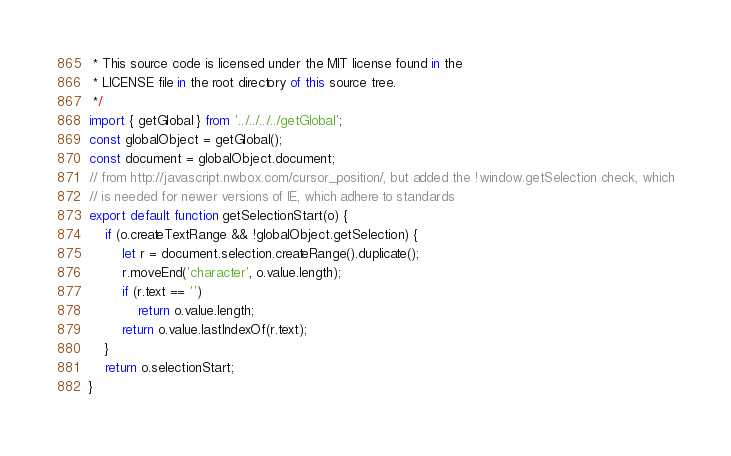Convert code to text. <code><loc_0><loc_0><loc_500><loc_500><_JavaScript_> * This source code is licensed under the MIT license found in the
 * LICENSE file in the root directory of this source tree.
 */
import { getGlobal } from '../../../../getGlobal';
const globalObject = getGlobal();
const document = globalObject.document;
// from http://javascript.nwbox.com/cursor_position/, but added the !window.getSelection check, which
// is needed for newer versions of IE, which adhere to standards
export default function getSelectionStart(o) {
    if (o.createTextRange && !globalObject.getSelection) {
        let r = document.selection.createRange().duplicate();
        r.moveEnd('character', o.value.length);
        if (r.text == '')
            return o.value.length;
        return o.value.lastIndexOf(r.text);
    }
    return o.selectionStart;
}
</code> 